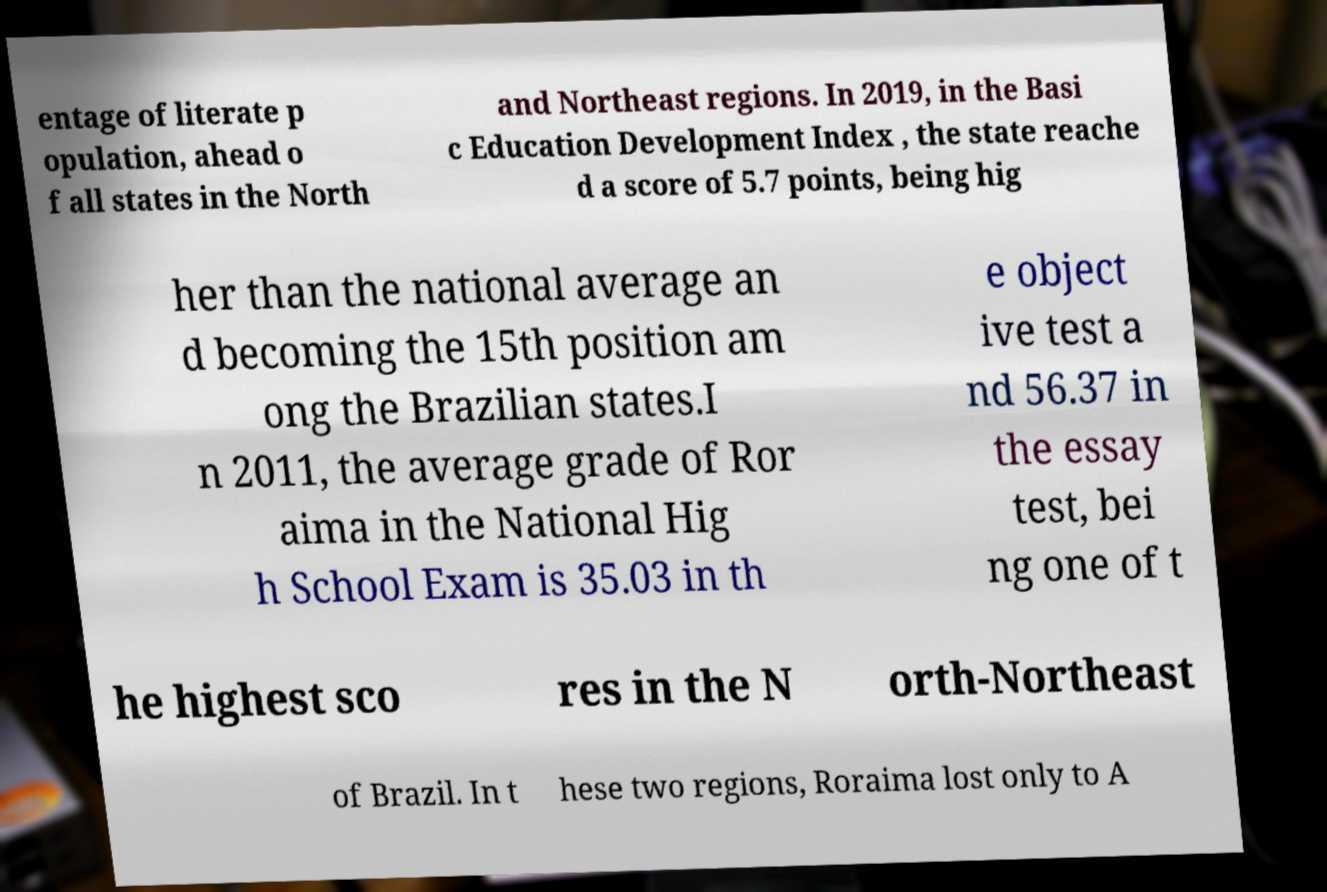What messages or text are displayed in this image? I need them in a readable, typed format. entage of literate p opulation, ahead o f all states in the North and Northeast regions. In 2019, in the Basi c Education Development Index , the state reache d a score of 5.7 points, being hig her than the national average an d becoming the 15th position am ong the Brazilian states.I n 2011, the average grade of Ror aima in the National Hig h School Exam is 35.03 in th e object ive test a nd 56.37 in the essay test, bei ng one of t he highest sco res in the N orth-Northeast of Brazil. In t hese two regions, Roraima lost only to A 